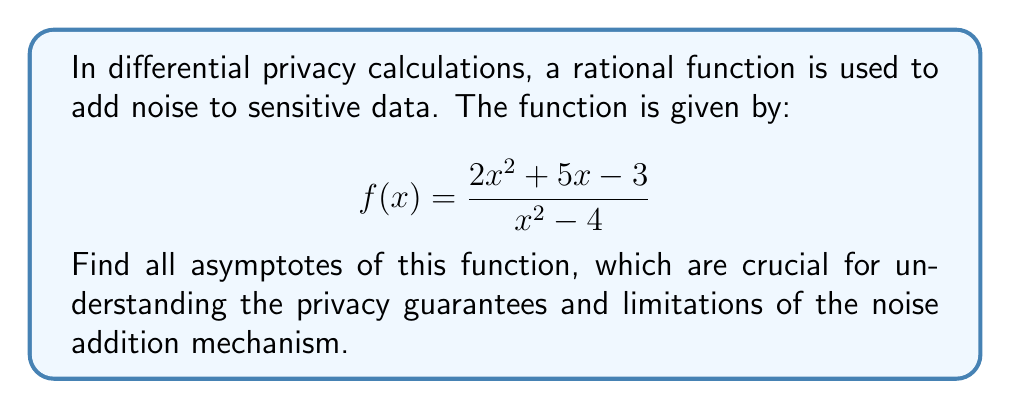Give your solution to this math problem. To find the asymptotes of the rational function, we need to follow these steps:

1. Vertical asymptotes:
   Set the denominator to zero and solve for x.
   $$x^2 - 4 = 0$$
   $$(x+2)(x-2) = 0$$
   $$x = -2 \text{ or } x = 2$$
   
   Therefore, the vertical asymptotes are at x = -2 and x = 2.

2. Horizontal asymptote:
   Compare the degrees of the numerator and denominator.
   Numerator degree: 2
   Denominator degree: 2
   
   Since the degrees are equal, the horizontal asymptote is the ratio of the leading coefficients:
   $$y = \frac{2}{1} = 2$$

3. Slant asymptote:
   Since the degree of the numerator is equal to the degree of the denominator, there is no slant asymptote.

To verify the horizontal asymptote, we can use the limit as x approaches infinity:

$$\lim_{x \to \infty} \frac{2x^2 + 5x - 3}{x^2 - 4} = \lim_{x \to \infty} \frac{2 + \frac{5}{x} - \frac{3}{x^2}}{1 - \frac{4}{x^2}} = 2$$

This confirms our earlier calculation of the horizontal asymptote.
Answer: Vertical asymptotes: x = -2, x = 2; Horizontal asymptote: y = 2 